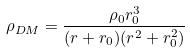Convert formula to latex. <formula><loc_0><loc_0><loc_500><loc_500>\rho _ { D M } = \frac { \rho _ { 0 } r _ { 0 } ^ { 3 } } { ( r + r _ { 0 } ) ( r ^ { 2 } + r _ { 0 } ^ { 2 } ) }</formula> 